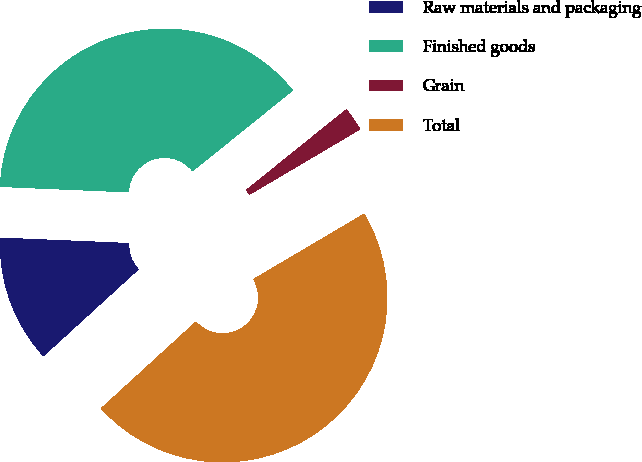Convert chart. <chart><loc_0><loc_0><loc_500><loc_500><pie_chart><fcel>Raw materials and packaging<fcel>Finished goods<fcel>Grain<fcel>Total<nl><fcel>12.45%<fcel>38.54%<fcel>2.3%<fcel>46.71%<nl></chart> 